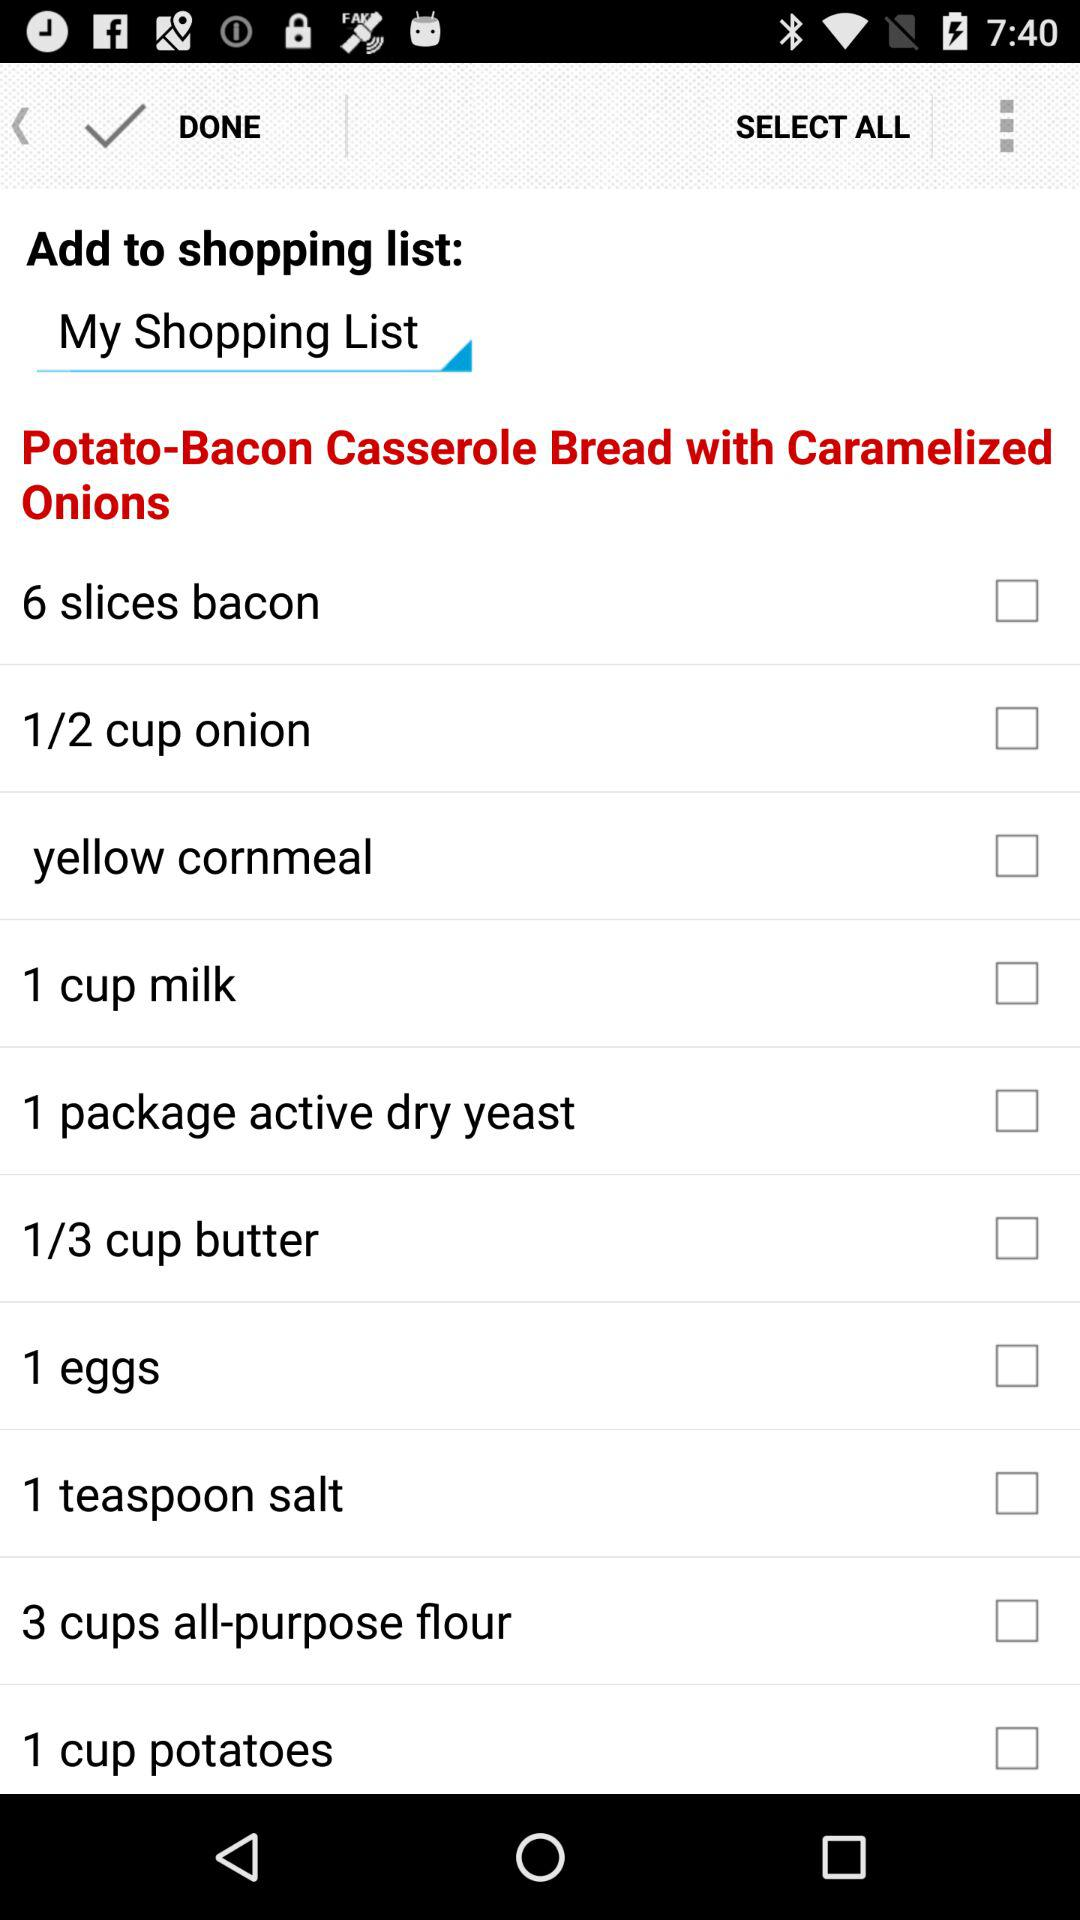To which shopping list items will be added? The items will be added to "My Shopping List". 